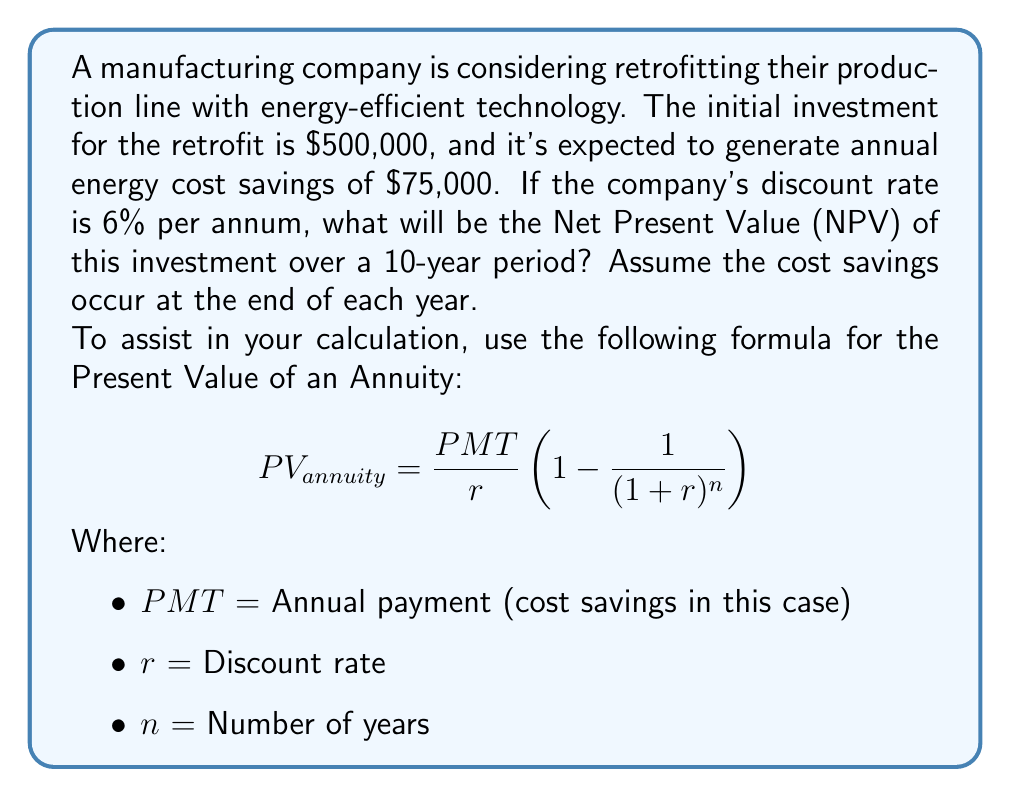Solve this math problem. Let's approach this step-by-step:

1) First, we need to calculate the Present Value of the cost savings over 10 years. We'll use the given formula:

   $$PV_{annuity} = \frac{PMT}{r} \left(1 - \frac{1}{(1+r)^n}\right)$$

   Where:
   $PMT = 75,000$
   $r = 0.06$ (6%)
   $n = 10$ years

2) Plugging in these values:

   $$PV_{annuity} = \frac{75,000}{0.06} \left(1 - \frac{1}{(1+0.06)^{10}}\right)$$

3) Simplify:

   $$PV_{annuity} = 1,250,000 \left(1 - \frac{1}{1.7908}\right)$$
   $$PV_{annuity} = 1,250,000 (1 - 0.5584)$$
   $$PV_{annuity} = 1,250,000 (0.4416)$$
   $$PV_{annuity} = 552,000$$

4) Now, to calculate the NPV, we subtract the initial investment from the Present Value of the cost savings:

   $$NPV = PV_{annuity} - Initial Investment$$
   $$NPV = 552,000 - 500,000$$
   $$NPV = 52,000$$

Therefore, the Net Present Value of the investment over a 10-year period is $52,000.
Answer: $52,000 